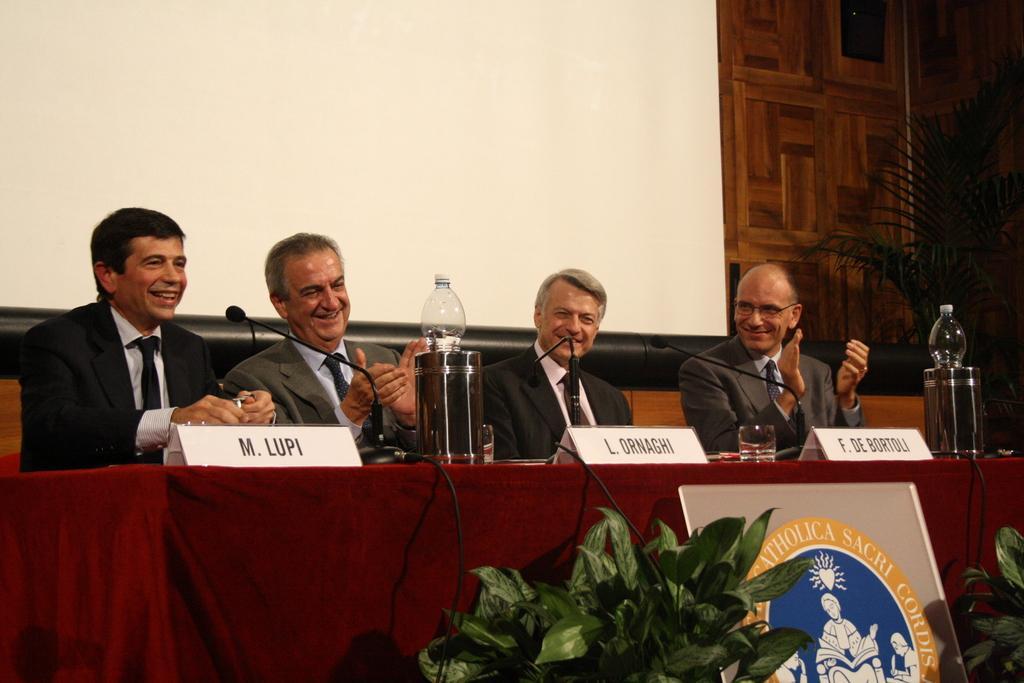Please provide a concise description of this image. In this picture we can see a few people sitting on the chairs. We can see the text, images of people and a few things on the boards. There are bottles and some objects visible on the table. We can see a few leaves, a projector screen and other objects. 